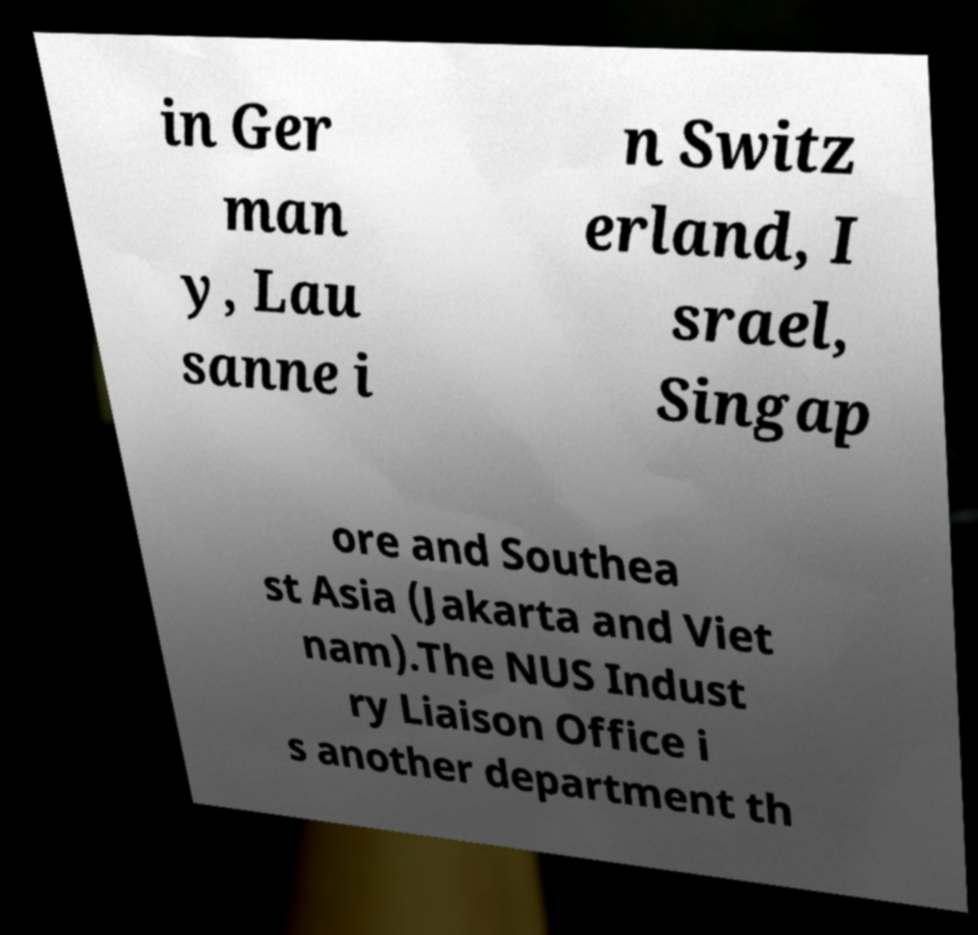Can you accurately transcribe the text from the provided image for me? in Ger man y, Lau sanne i n Switz erland, I srael, Singap ore and Southea st Asia (Jakarta and Viet nam).The NUS Indust ry Liaison Office i s another department th 